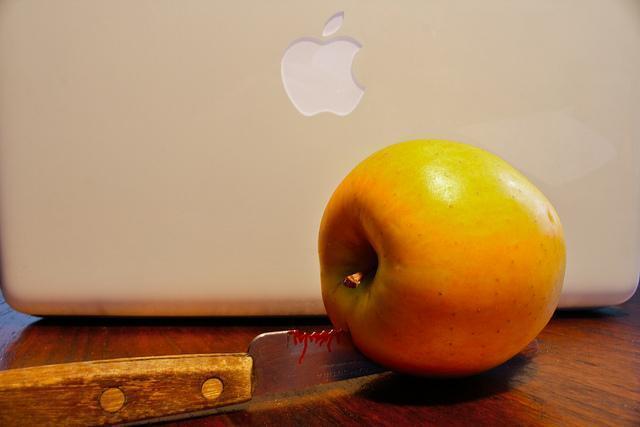Does the caption "The apple is under the knife." correctly depict the image?
Answer yes or no. No. 